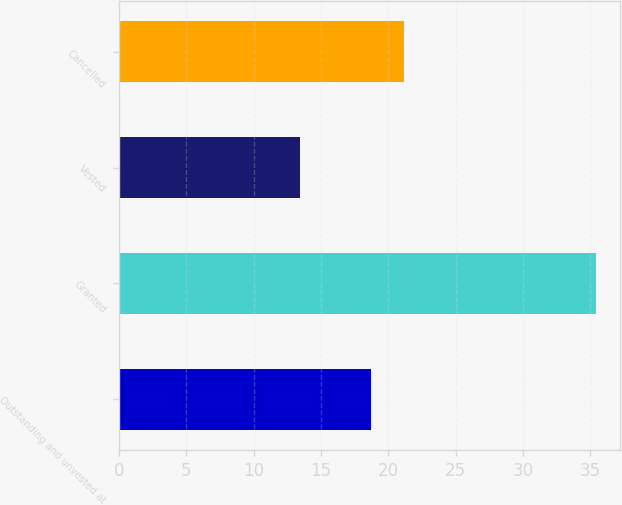Convert chart to OTSL. <chart><loc_0><loc_0><loc_500><loc_500><bar_chart><fcel>Outstanding and unvested at<fcel>Granted<fcel>Vested<fcel>Cancelled<nl><fcel>18.72<fcel>35.46<fcel>13.46<fcel>21.16<nl></chart> 